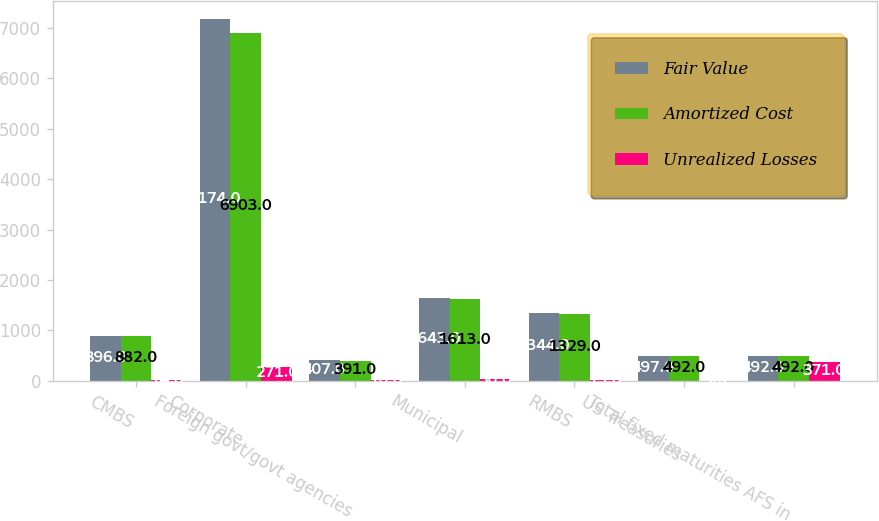Convert chart to OTSL. <chart><loc_0><loc_0><loc_500><loc_500><stacked_bar_chart><ecel><fcel>CMBS<fcel>Corporate<fcel>Foreign govt/govt agencies<fcel>Municipal<fcel>RMBS<fcel>US Treasuries<fcel>Total fixed maturities AFS in<nl><fcel>Fair Value<fcel>896<fcel>7174<fcel>407<fcel>1643<fcel>1344<fcel>497<fcel>492<nl><fcel>Amortized Cost<fcel>882<fcel>6903<fcel>391<fcel>1613<fcel>1329<fcel>492<fcel>492<nl><fcel>Unrealized Losses<fcel>14<fcel>271<fcel>16<fcel>30<fcel>15<fcel>5<fcel>371<nl></chart> 